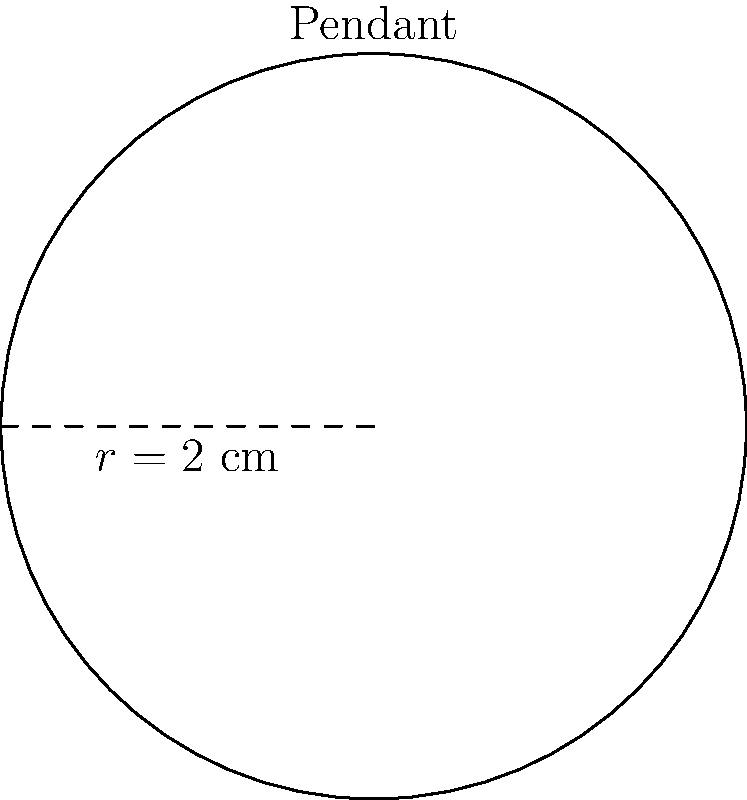You're designing a circular pendant necklace inspired by Vera Wang's minimalist aesthetic. If the radius of the pendant is 2 cm, what is the area of the pendant's face? Round your answer to two decimal places. To find the area of a circular pendant, we need to use the formula for the area of a circle:

$$A = \pi r^2$$

Where:
$A$ is the area of the circle
$\pi$ (pi) is approximately 3.14159
$r$ is the radius of the circle

Given:
$r = 2$ cm

Let's substitute these values into the formula:

$$\begin{align*}
A &= \pi r^2 \\
A &= \pi (2 \text{ cm})^2 \\
A &= \pi (4 \text{ cm}^2) \\
A &\approx 3.14159 \times 4 \text{ cm}^2 \\
A &\approx 12.56636 \text{ cm}^2
\end{align*}$$

Rounding to two decimal places:

$$A \approx 12.57 \text{ cm}^2$$

This sleek, minimalist pendant design aligns perfectly with Vera Wang's aesthetic, showcasing geometric simplicity in fashion accessories.
Answer: $12.57 \text{ cm}^2$ 